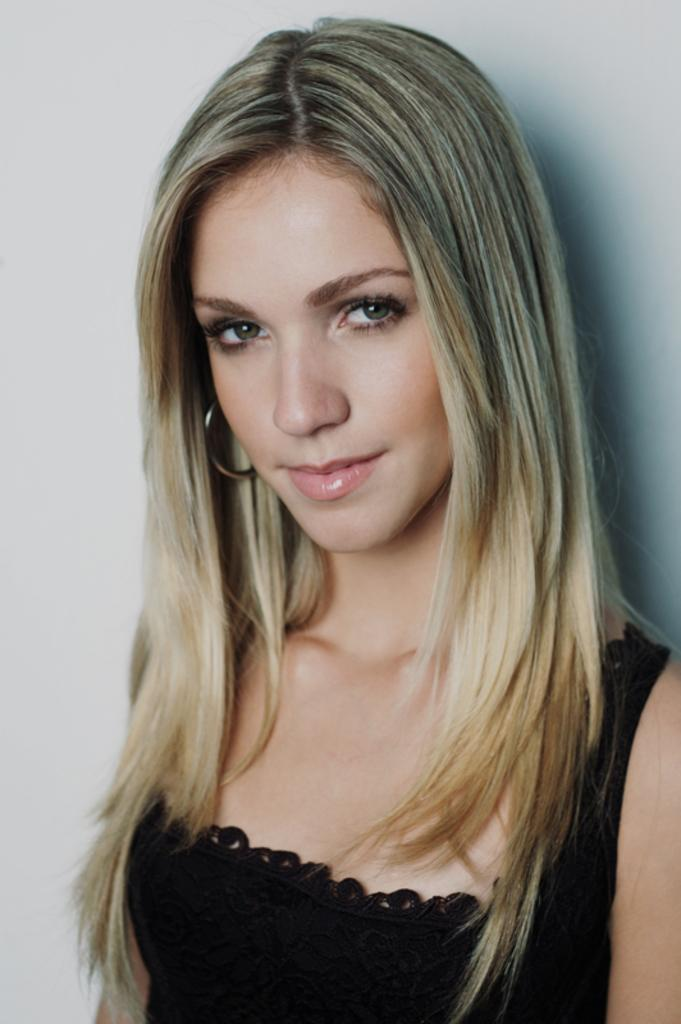What is the main subject of the image? There is a lady in the image. Can you describe the lady's attire? The lady is wearing a black dress. What type of toothpaste is the lady holding in the image? There is no toothpaste present in the image; the lady is wearing a black dress. 